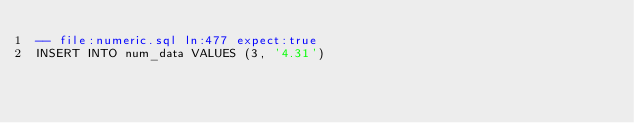<code> <loc_0><loc_0><loc_500><loc_500><_SQL_>-- file:numeric.sql ln:477 expect:true
INSERT INTO num_data VALUES (3, '4.31')
</code> 